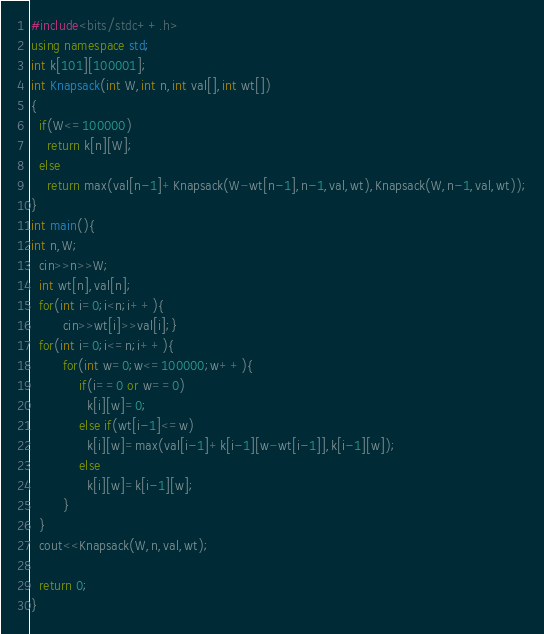Convert code to text. <code><loc_0><loc_0><loc_500><loc_500><_C++_>#include<bits/stdc++.h>
using namespace std;
int k[101][100001];
int Knapsack(int W,int n,int val[],int wt[])
{
  if(W<=100000)
    return k[n][W];
  else
    return max(val[n-1]+Knapsack(W-wt[n-1],n-1,val,wt),Knapsack(W,n-1,val,wt));
}
int main(){
int n,W;
  cin>>n>>W;
  int wt[n],val[n];
  for(int i=0;i<n;i++){
		cin>>wt[i]>>val[i];}
  for(int i=0;i<=n;i++){
		for(int w=0;w<=100000;w++){
			if(i==0 or w==0)
              k[i][w]=0;
          	else if(wt[i-1]<=w)
              k[i][w]=max(val[i-1]+k[i-1][w-wt[i-1]],k[i-1][w]);
          	else
              k[i][w]=k[i-1][w];
        }
  }
  cout<<Knapsack(W,n,val,wt);
  
  return 0;
}</code> 